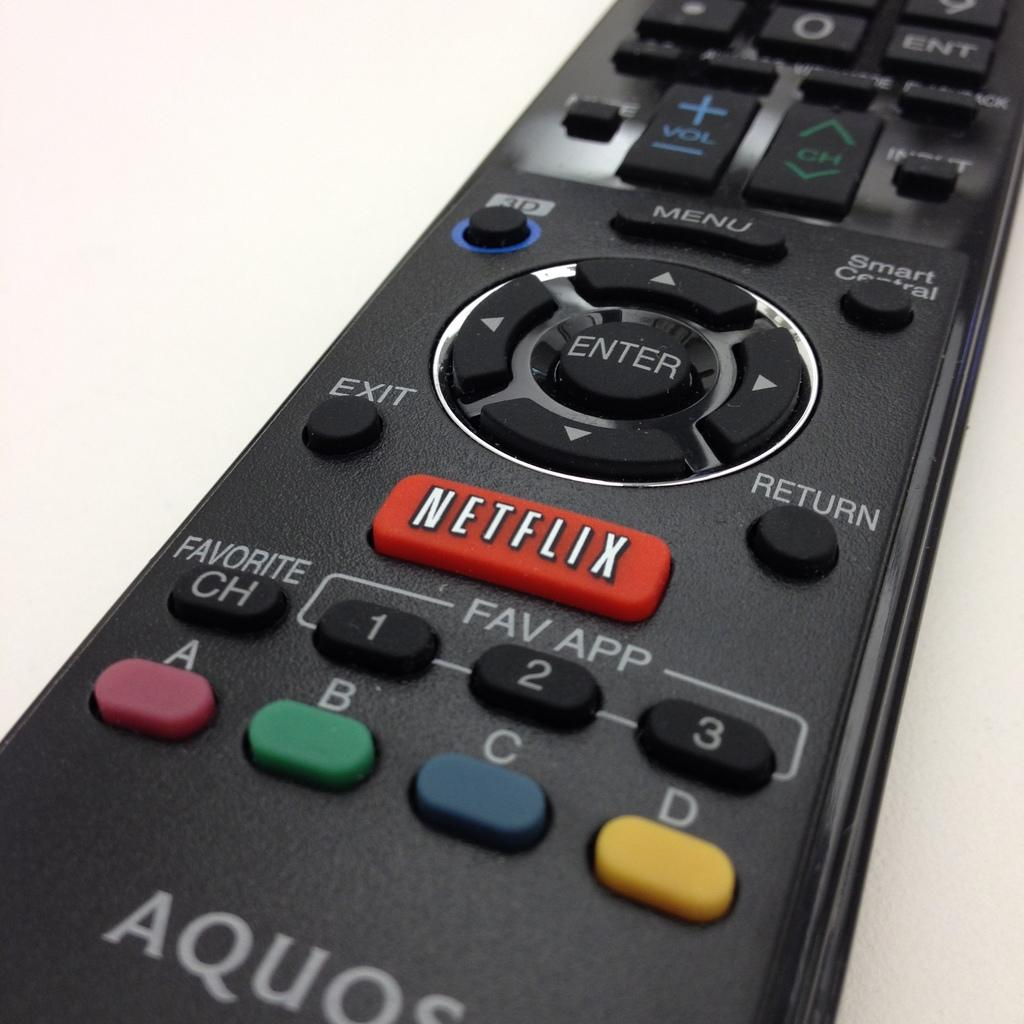<image>
Relay a brief, clear account of the picture shown. A TV remote control has a large Netflix button on it. 